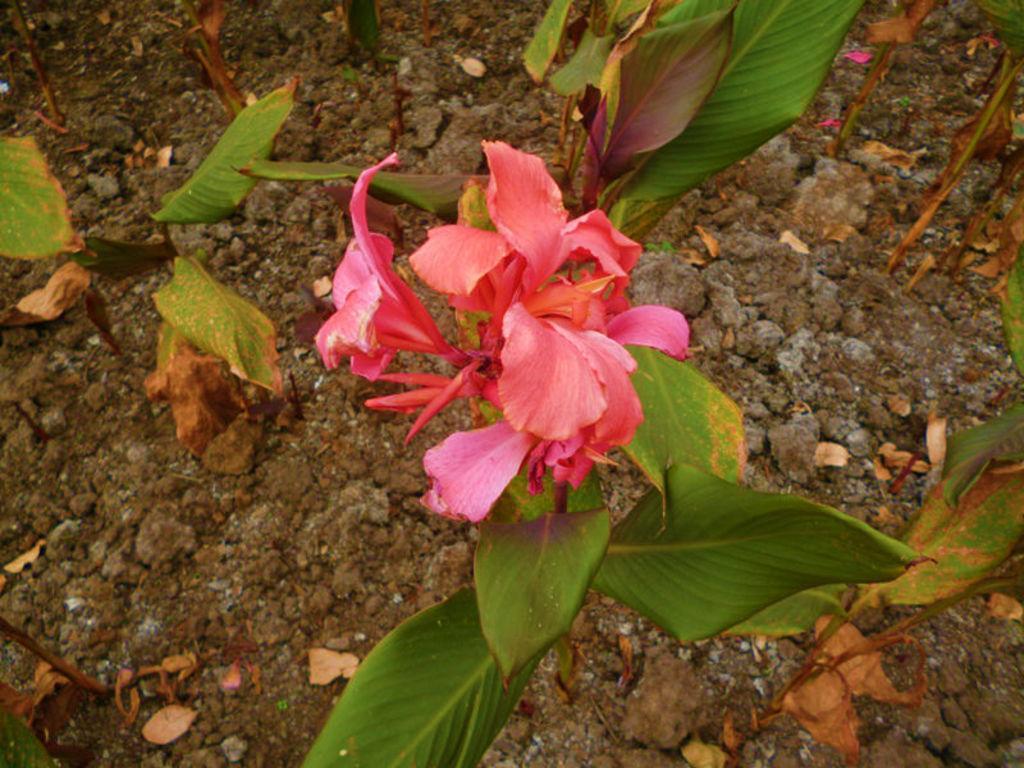How would you summarize this image in a sentence or two? In this image I can see few flowers in pink color and leaves in green color. 